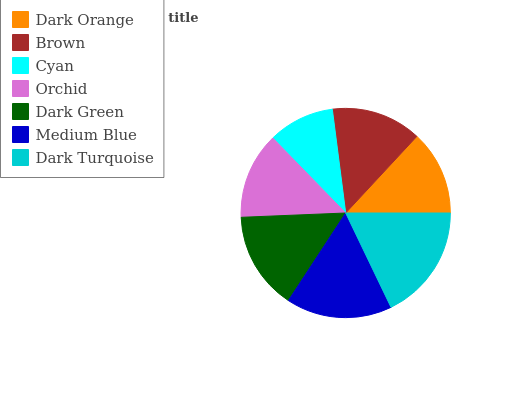Is Cyan the minimum?
Answer yes or no. Yes. Is Dark Turquoise the maximum?
Answer yes or no. Yes. Is Brown the minimum?
Answer yes or no. No. Is Brown the maximum?
Answer yes or no. No. Is Brown greater than Dark Orange?
Answer yes or no. Yes. Is Dark Orange less than Brown?
Answer yes or no. Yes. Is Dark Orange greater than Brown?
Answer yes or no. No. Is Brown less than Dark Orange?
Answer yes or no. No. Is Brown the high median?
Answer yes or no. Yes. Is Brown the low median?
Answer yes or no. Yes. Is Orchid the high median?
Answer yes or no. No. Is Dark Orange the low median?
Answer yes or no. No. 